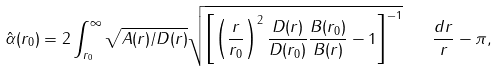<formula> <loc_0><loc_0><loc_500><loc_500>\hat { \alpha } ( r _ { 0 } ) = 2 \int _ { r _ { 0 } } ^ { \infty } \sqrt { A ( r ) / D ( r ) } \sqrt { \left [ \left ( \frac { r } { r _ { 0 } } \right ) ^ { 2 } \frac { D ( r ) } { D ( r _ { 0 } ) } \frac { B ( r _ { 0 } ) } { B ( r ) } - 1 \right ] ^ { - 1 } } \quad \frac { d r } { r } - \pi ,</formula> 